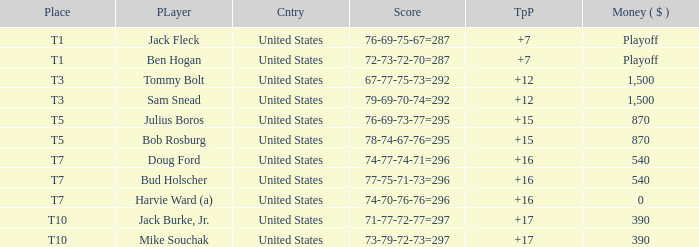What is average to par when Bud Holscher is the player? 16.0. 